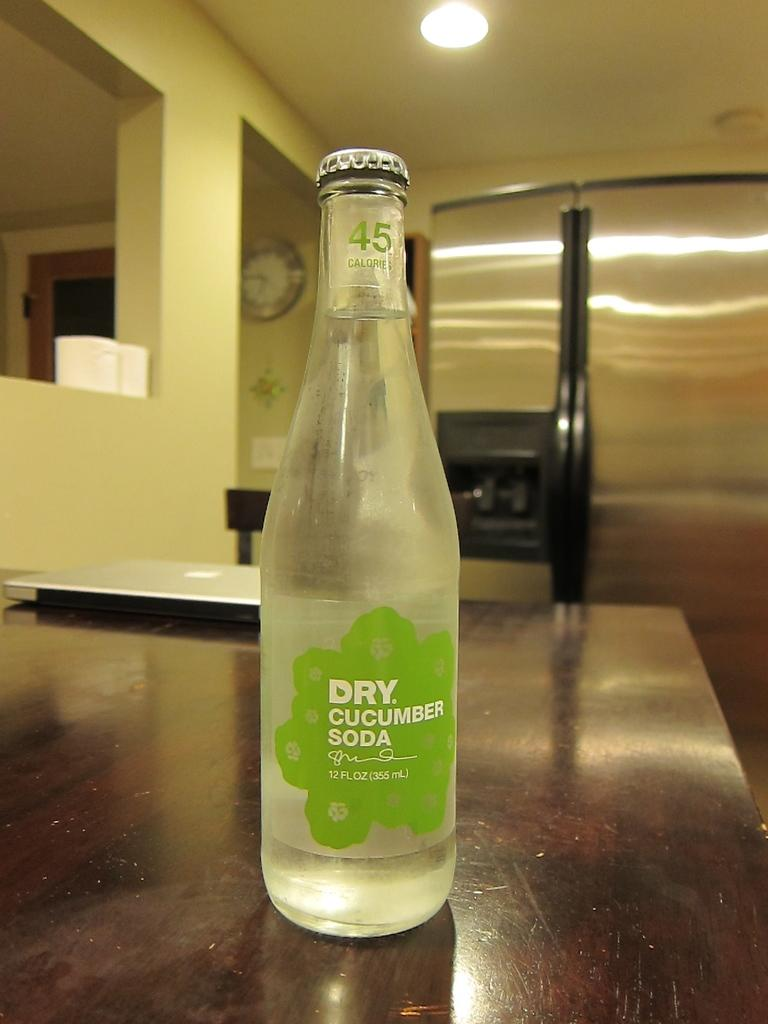<image>
Share a concise interpretation of the image provided. A bottle of Dry Cucumber Soda sits on a counter near a laptop 